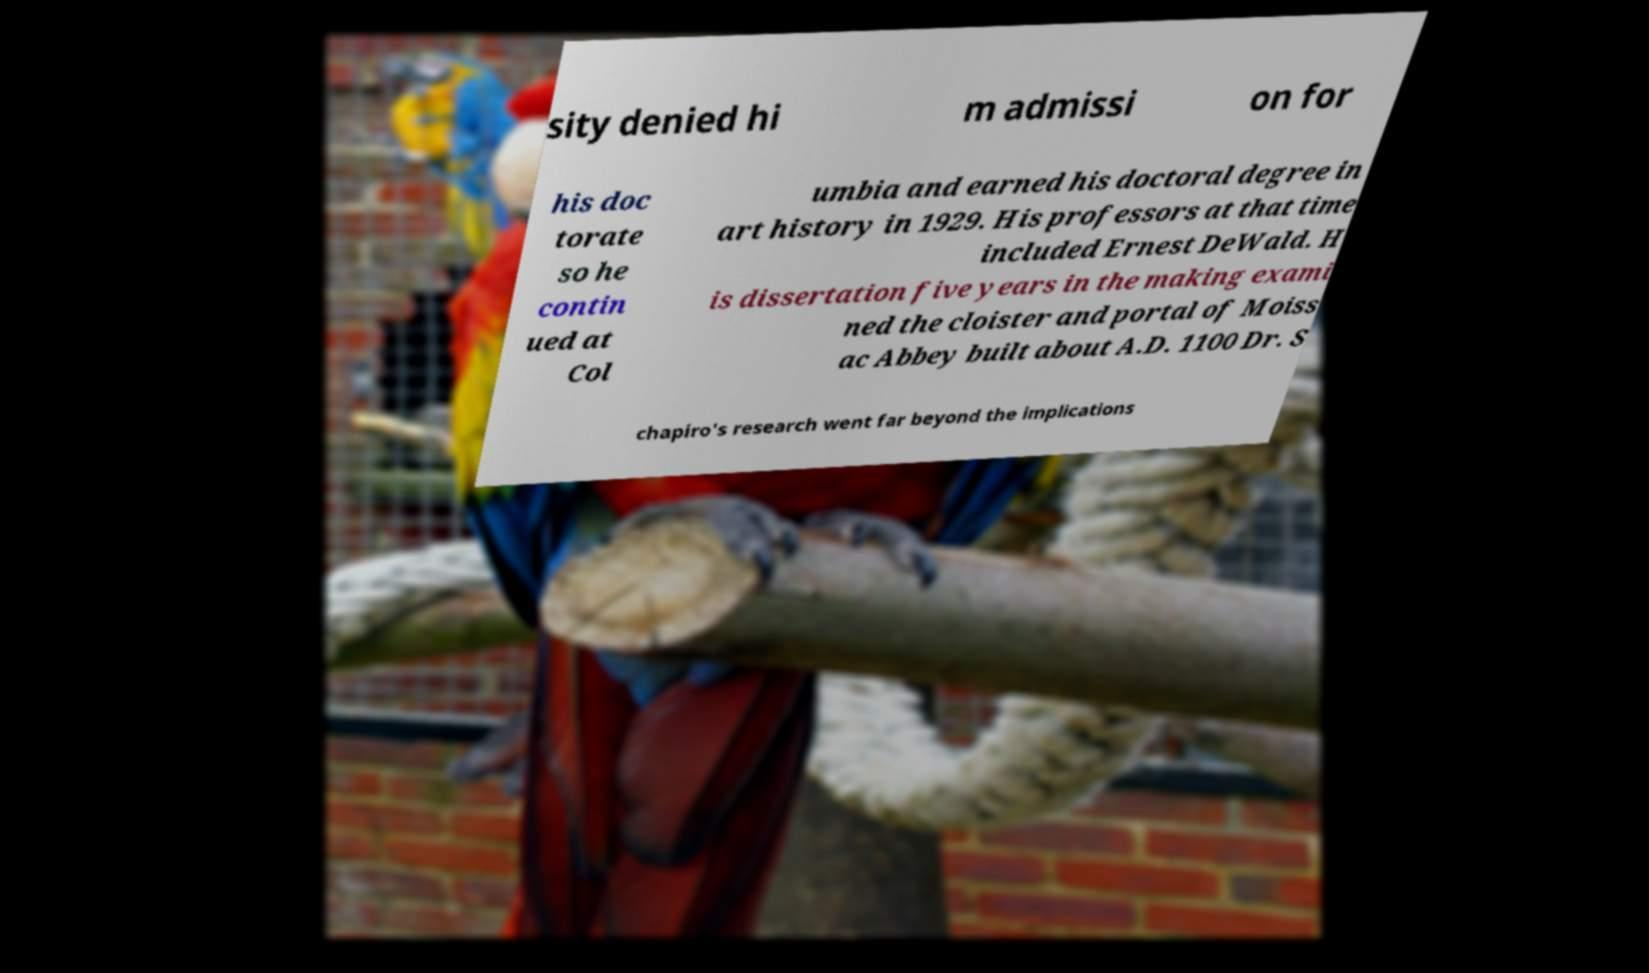What messages or text are displayed in this image? I need them in a readable, typed format. sity denied hi m admissi on for his doc torate so he contin ued at Col umbia and earned his doctoral degree in art history in 1929. His professors at that time included Ernest DeWald. H is dissertation five years in the making exami ned the cloister and portal of Moiss ac Abbey built about A.D. 1100 Dr. S chapiro's research went far beyond the implications 